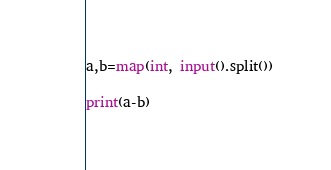<code> <loc_0><loc_0><loc_500><loc_500><_Python_>a,b=map(int, input().split())

print(a-b)
</code> 